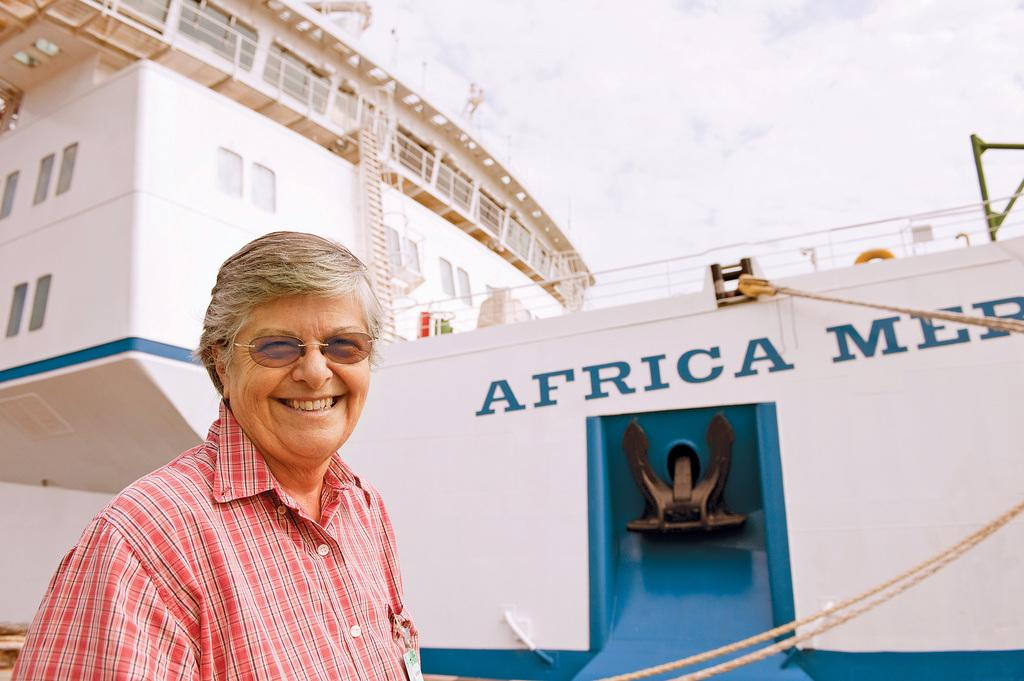Who is present in the image? There is a man in the image. What is the man wearing? The man is wearing glasses. What is the man's facial expression? The man is smiling. What can be seen in the background of the image? There is a white color ship with text in the background. What objects are visible in the image? Ropes are visible in the image. What is visible in the sky in the background? The sky is visible with clouds in the background. How many ladybugs are crawling on the man's glasses in the image? There are no ladybugs present in the image; the man is wearing glasses, but there are no insects visible. 